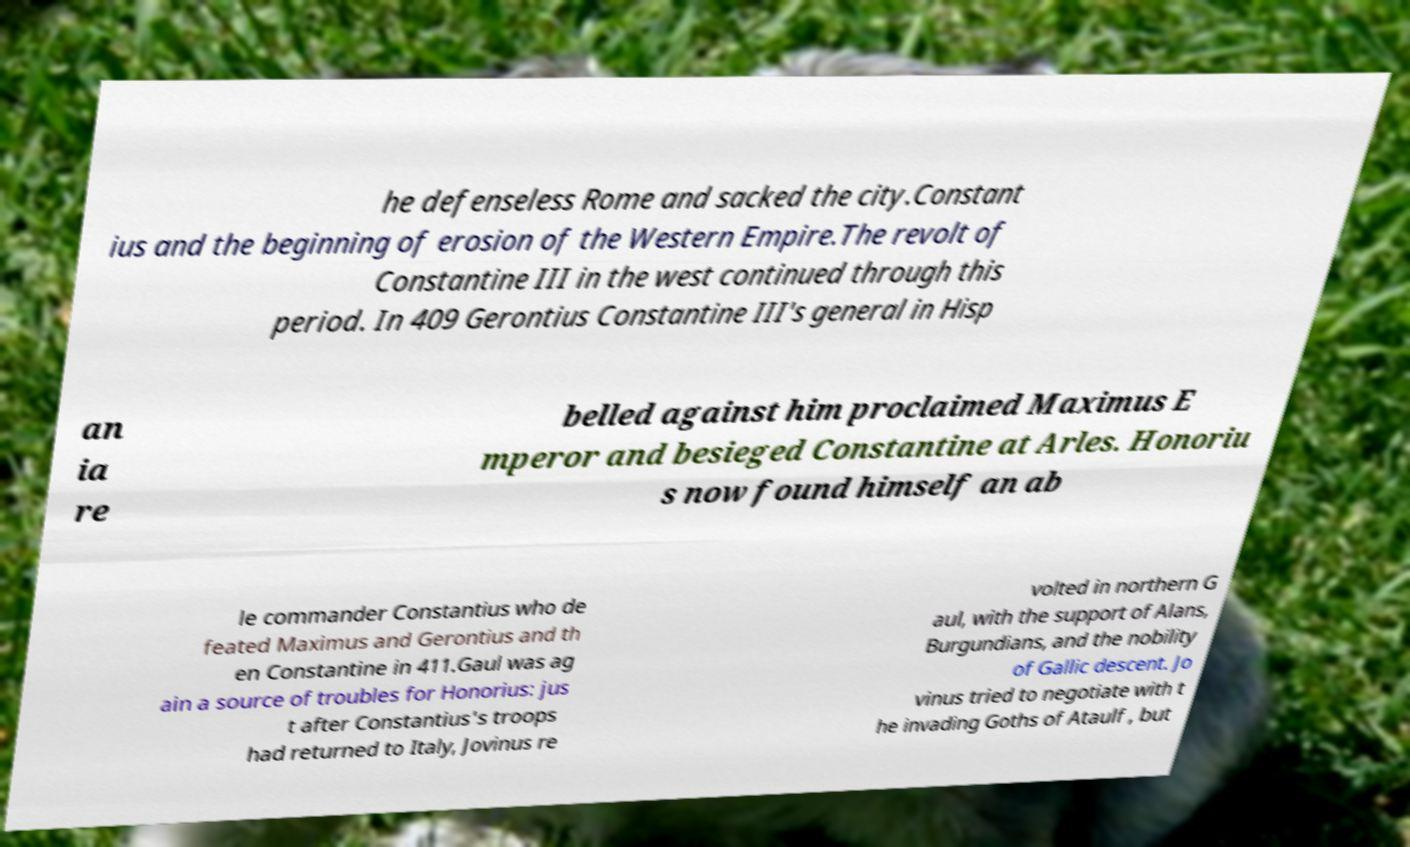I need the written content from this picture converted into text. Can you do that? he defenseless Rome and sacked the city.Constant ius and the beginning of erosion of the Western Empire.The revolt of Constantine III in the west continued through this period. In 409 Gerontius Constantine III's general in Hisp an ia re belled against him proclaimed Maximus E mperor and besieged Constantine at Arles. Honoriu s now found himself an ab le commander Constantius who de feated Maximus and Gerontius and th en Constantine in 411.Gaul was ag ain a source of troubles for Honorius: jus t after Constantius's troops had returned to Italy, Jovinus re volted in northern G aul, with the support of Alans, Burgundians, and the nobility of Gallic descent. Jo vinus tried to negotiate with t he invading Goths of Ataulf , but 